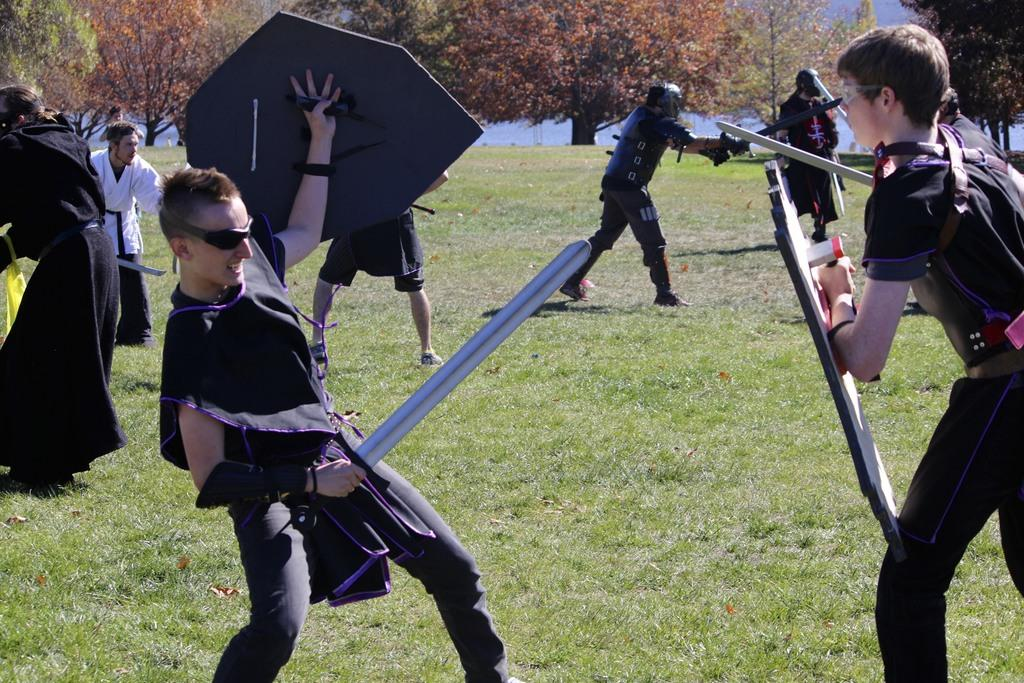How many people are in the image? There are people in the image, but the exact number is not specified. What are the people holding in the image? The people are holding objects in the image. What type of terrain is visible in the image? There is ground with grass visible in the image. What other natural elements can be seen in the image? There are trees in the image. What is visible in the background of the image? The sky is visible in the image. What color is the tongue of the person in the image? There is no mention of a tongue in the image, so it cannot be determined what color it might be. 